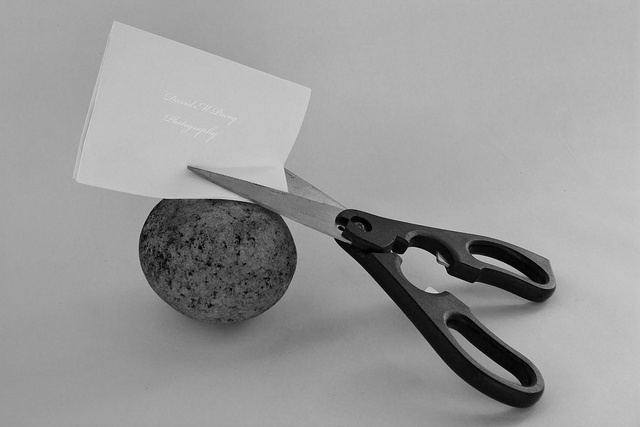Describe the objects in this image and their specific colors. I can see scissors in darkgray, black, gray, and lightgray tones in this image. 